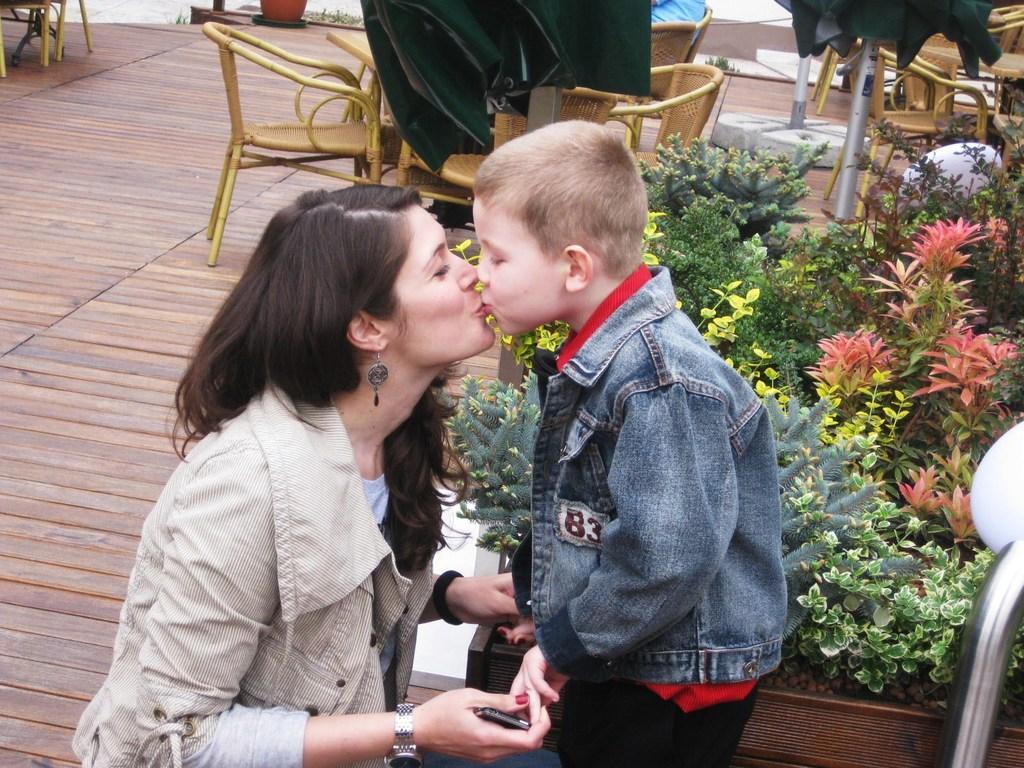How would you summarize this image in a sentence or two? It seems to be outdoor restaurant. There is boy and woman wearing jacket kissing each other and there are plants beside them,there are chairs and tables backside of them. 